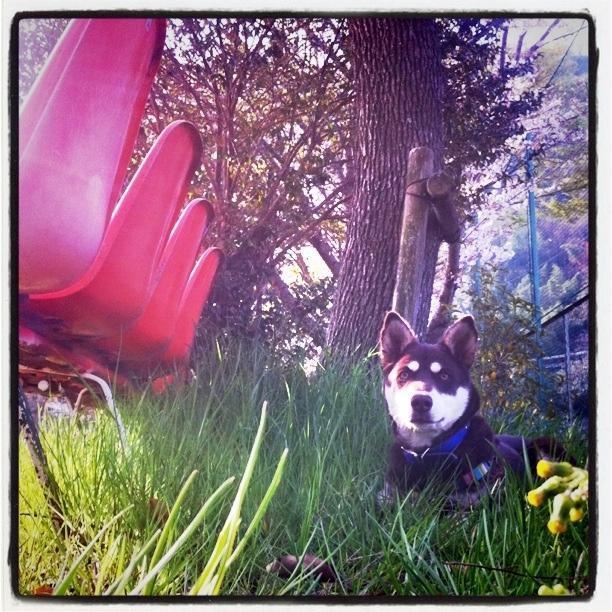How many chairs are in the picture?
Give a very brief answer. 4. 